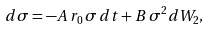<formula> <loc_0><loc_0><loc_500><loc_500>d \sigma = - A \, r _ { 0 } \, \sigma \, d t + B \, \sigma ^ { 2 } d W _ { 2 } ,</formula> 